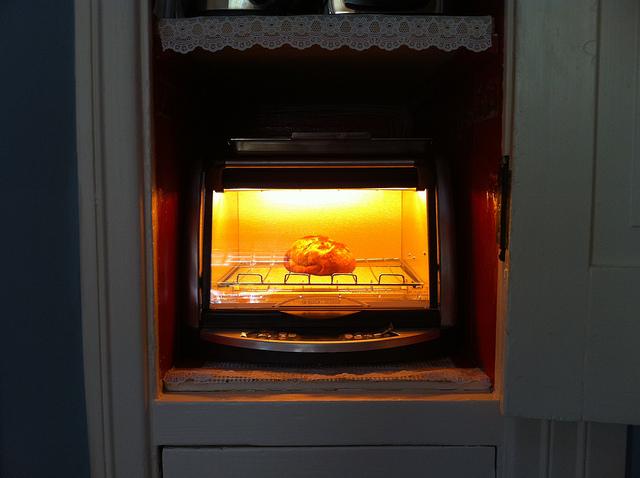Is the skin golden brown?
Give a very brief answer. Yes. What color is the cabinet?
Concise answer only. White. Is this a cat being cooked?
Quick response, please. No. 